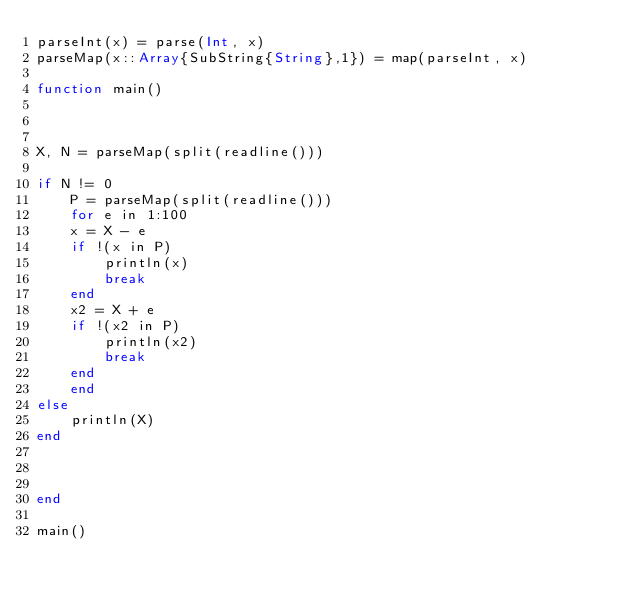<code> <loc_0><loc_0><loc_500><loc_500><_Julia_>parseInt(x) = parse(Int, x)
parseMap(x::Array{SubString{String},1}) = map(parseInt, x)

function main()



X, N = parseMap(split(readline()))

if N != 0
    P = parseMap(split(readline()))
    for e in 1:100
    x = X - e
    if !(x in P)
        println(x)
        break
    end
    x2 = X + e
    if !(x2 in P)
        println(x2)
        break
    end
    end
else
    println(X)
end



end

main()
</code> 